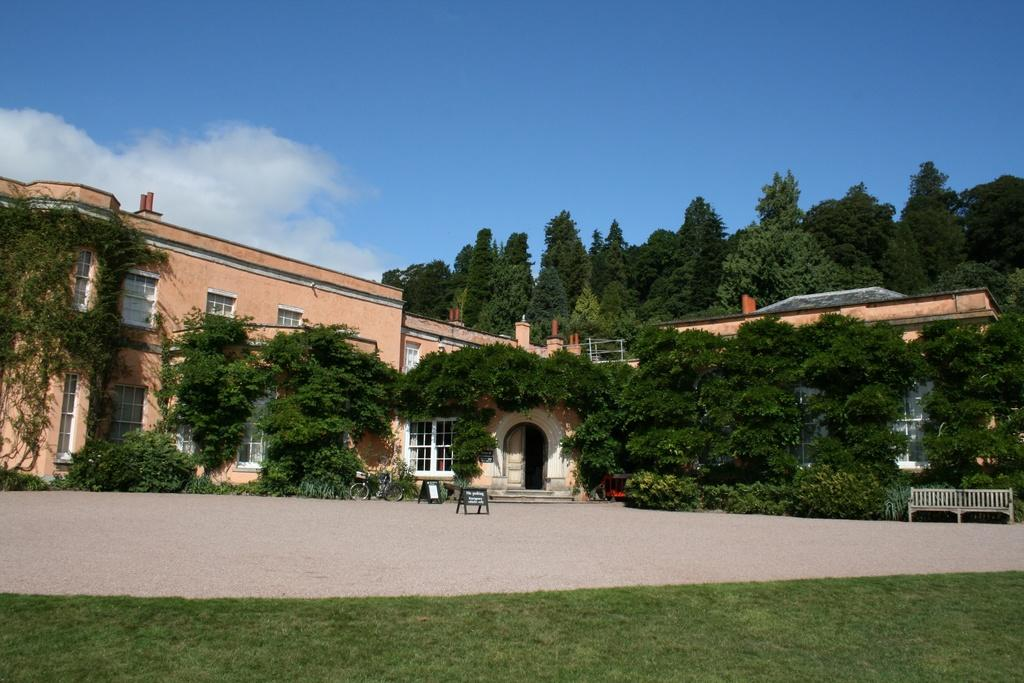What type of structures can be seen in the image? There are buildings in the image. What architectural features can be observed on the buildings? There are windows visible on the buildings. What type of vegetation is present in the image? There are trees and plants in the image. What mode of transportation is present in the image? There is a bicycle in the image. What type of signage or display can be seen in the image? There are boards in the image. What type of seating is available in the image? There is a bench in the image. What type of ground cover is present in the image? There is grass in the image. What can be seen in the background of the image? The sky is visible in the background of the image. Where is the boot located in the image? There is no boot present in the image. What type of net can be seen in the image? There is no net present in the image. 